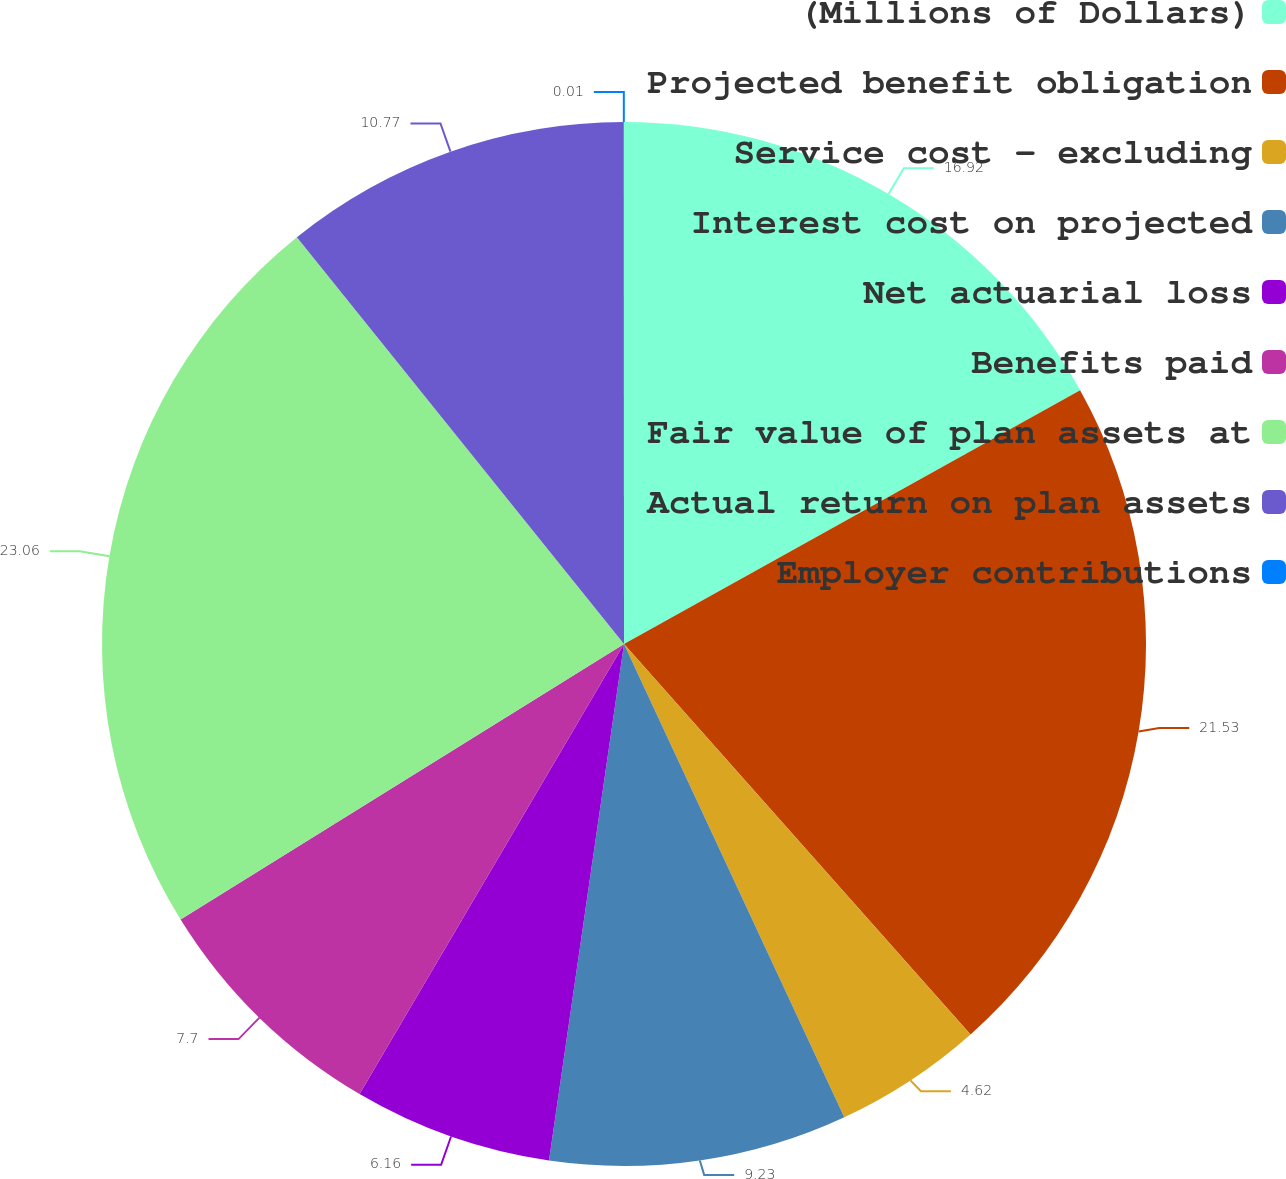<chart> <loc_0><loc_0><loc_500><loc_500><pie_chart><fcel>(Millions of Dollars)<fcel>Projected benefit obligation<fcel>Service cost - excluding<fcel>Interest cost on projected<fcel>Net actuarial loss<fcel>Benefits paid<fcel>Fair value of plan assets at<fcel>Actual return on plan assets<fcel>Employer contributions<nl><fcel>16.92%<fcel>21.53%<fcel>4.62%<fcel>9.23%<fcel>6.16%<fcel>7.7%<fcel>23.07%<fcel>10.77%<fcel>0.01%<nl></chart> 